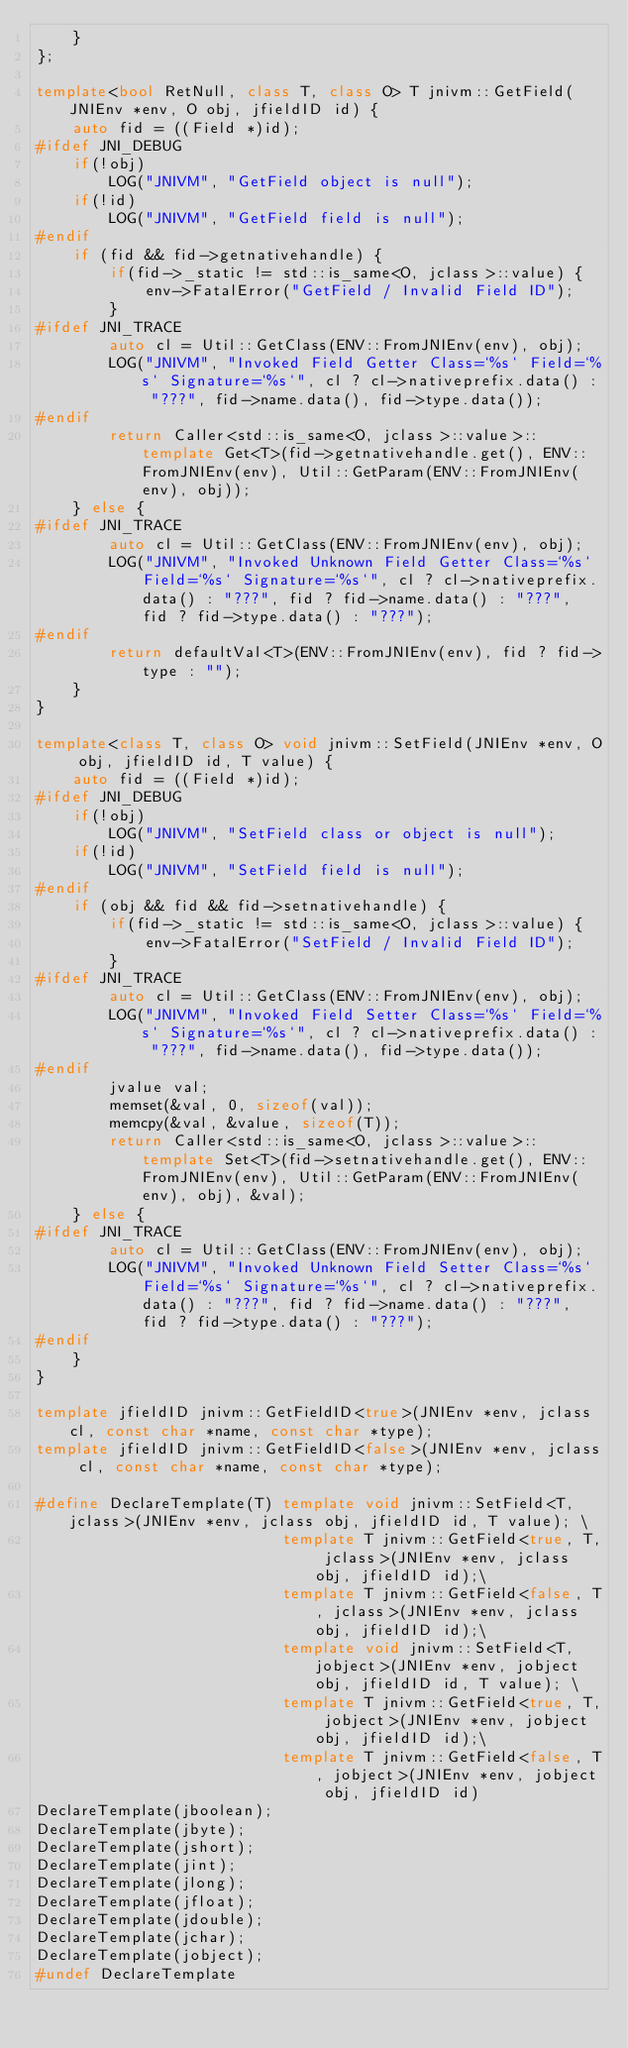<code> <loc_0><loc_0><loc_500><loc_500><_C++_>    }
};

template<bool RetNull, class T, class O> T jnivm::GetField(JNIEnv *env, O obj, jfieldID id) {
    auto fid = ((Field *)id);
#ifdef JNI_DEBUG
    if(!obj)
        LOG("JNIVM", "GetField object is null");
    if(!id)
        LOG("JNIVM", "GetField field is null");
#endif
    if (fid && fid->getnativehandle) {
        if(fid->_static != std::is_same<O, jclass>::value) {
            env->FatalError("GetField / Invalid Field ID");
        }
#ifdef JNI_TRACE
        auto cl = Util::GetClass(ENV::FromJNIEnv(env), obj);
        LOG("JNIVM", "Invoked Field Getter Class=`%s` Field=`%s` Signature=`%s`", cl ? cl->nativeprefix.data() : "???", fid->name.data(), fid->type.data());
#endif
        return Caller<std::is_same<O, jclass>::value>::template Get<T>(fid->getnativehandle.get(), ENV::FromJNIEnv(env), Util::GetParam(ENV::FromJNIEnv(env), obj));
    } else {
#ifdef JNI_TRACE
        auto cl = Util::GetClass(ENV::FromJNIEnv(env), obj);
        LOG("JNIVM", "Invoked Unknown Field Getter Class=`%s` Field=`%s` Signature=`%s`", cl ? cl->nativeprefix.data() : "???", fid ? fid->name.data() : "???", fid ? fid->type.data() : "???");
#endif
        return defaultVal<T>(ENV::FromJNIEnv(env), fid ? fid->type : "");
    }
}

template<class T, class O> void jnivm::SetField(JNIEnv *env, O obj, jfieldID id, T value) {
    auto fid = ((Field *)id);
#ifdef JNI_DEBUG
    if(!obj)
        LOG("JNIVM", "SetField class or object is null");
    if(!id)
        LOG("JNIVM", "SetField field is null");
#endif
    if (obj && fid && fid->setnativehandle) {
        if(fid->_static != std::is_same<O, jclass>::value) {
            env->FatalError("SetField / Invalid Field ID");
        }
#ifdef JNI_TRACE
        auto cl = Util::GetClass(ENV::FromJNIEnv(env), obj);
        LOG("JNIVM", "Invoked Field Setter Class=`%s` Field=`%s` Signature=`%s`", cl ? cl->nativeprefix.data() : "???", fid->name.data(), fid->type.data());
#endif
        jvalue val;
        memset(&val, 0, sizeof(val));
        memcpy(&val, &value, sizeof(T));
        return Caller<std::is_same<O, jclass>::value>::template Set<T>(fid->setnativehandle.get(), ENV::FromJNIEnv(env), Util::GetParam(ENV::FromJNIEnv(env), obj), &val);
    } else {
#ifdef JNI_TRACE
        auto cl = Util::GetClass(ENV::FromJNIEnv(env), obj);
        LOG("JNIVM", "Invoked Unknown Field Setter Class=`%s` Field=`%s` Signature=`%s`", cl ? cl->nativeprefix.data() : "???", fid ? fid->name.data() : "???", fid ? fid->type.data() : "???");
#endif
    }
}

template jfieldID jnivm::GetFieldID<true>(JNIEnv *env, jclass cl, const char *name, const char *type);
template jfieldID jnivm::GetFieldID<false>(JNIEnv *env, jclass cl, const char *name, const char *type);

#define DeclareTemplate(T) template void jnivm::SetField<T, jclass>(JNIEnv *env, jclass obj, jfieldID id, T value); \
                           template T jnivm::GetField<true, T, jclass>(JNIEnv *env, jclass obj, jfieldID id);\
                           template T jnivm::GetField<false, T, jclass>(JNIEnv *env, jclass obj, jfieldID id);\
                           template void jnivm::SetField<T, jobject>(JNIEnv *env, jobject obj, jfieldID id, T value); \
                           template T jnivm::GetField<true, T, jobject>(JNIEnv *env, jobject obj, jfieldID id);\
                           template T jnivm::GetField<false, T, jobject>(JNIEnv *env, jobject obj, jfieldID id)
DeclareTemplate(jboolean);
DeclareTemplate(jbyte);
DeclareTemplate(jshort);
DeclareTemplate(jint);
DeclareTemplate(jlong);
DeclareTemplate(jfloat);
DeclareTemplate(jdouble);
DeclareTemplate(jchar);
DeclareTemplate(jobject);
#undef DeclareTemplate
</code> 